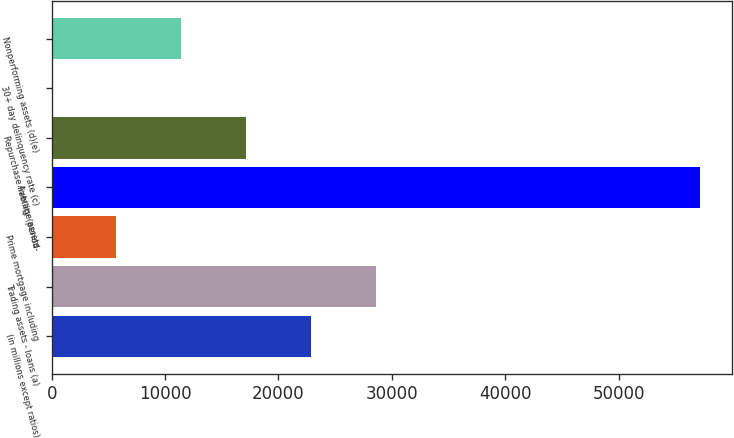Convert chart to OTSL. <chart><loc_0><loc_0><loc_500><loc_500><bar_chart><fcel>(in millions except ratios)<fcel>Trading assets - loans (a)<fcel>Prime mortgage including<fcel>Average assets<fcel>Repurchase liability (period-<fcel>30+ day delinquency rate (c)<fcel>Nonperforming assets (d)(e)<nl><fcel>22854.1<fcel>28566.9<fcel>5715.58<fcel>57131<fcel>17141.2<fcel>2.75<fcel>11428.4<nl></chart> 